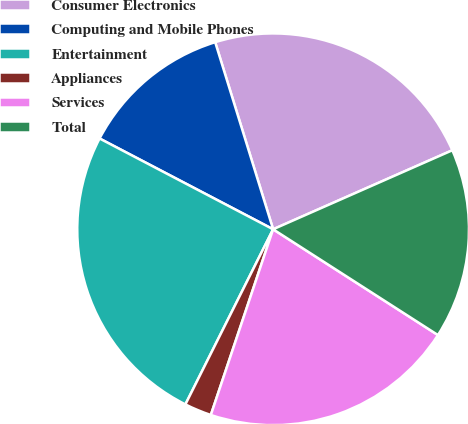<chart> <loc_0><loc_0><loc_500><loc_500><pie_chart><fcel>Consumer Electronics<fcel>Computing and Mobile Phones<fcel>Entertainment<fcel>Appliances<fcel>Services<fcel>Total<nl><fcel>23.17%<fcel>12.55%<fcel>25.28%<fcel>2.24%<fcel>21.07%<fcel>15.69%<nl></chart> 